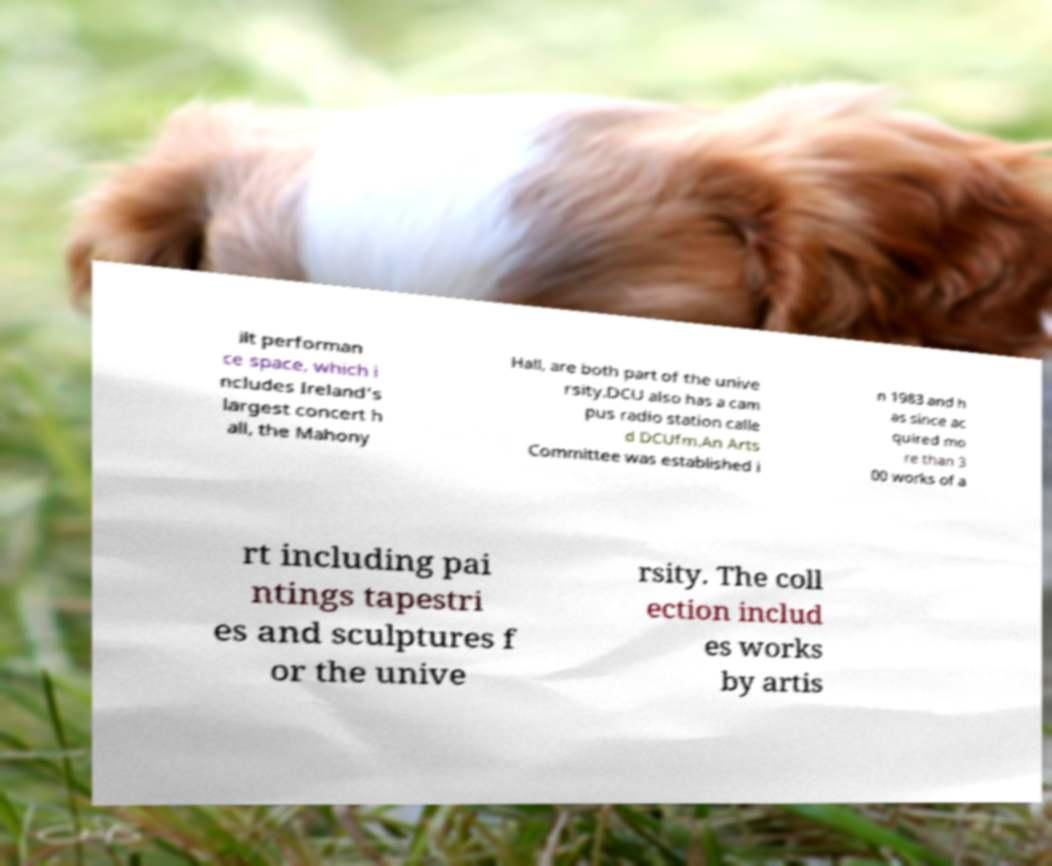What messages or text are displayed in this image? I need them in a readable, typed format. ilt performan ce space, which i ncludes Ireland's largest concert h all, the Mahony Hall, are both part of the unive rsity.DCU also has a cam pus radio station calle d DCUfm.An Arts Committee was established i n 1983 and h as since ac quired mo re than 3 00 works of a rt including pai ntings tapestri es and sculptures f or the unive rsity. The coll ection includ es works by artis 